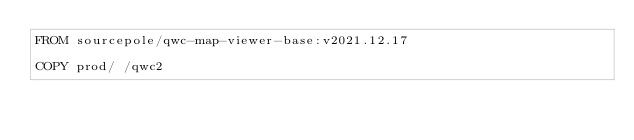Convert code to text. <code><loc_0><loc_0><loc_500><loc_500><_Dockerfile_>FROM sourcepole/qwc-map-viewer-base:v2021.12.17

COPY prod/ /qwc2
</code> 